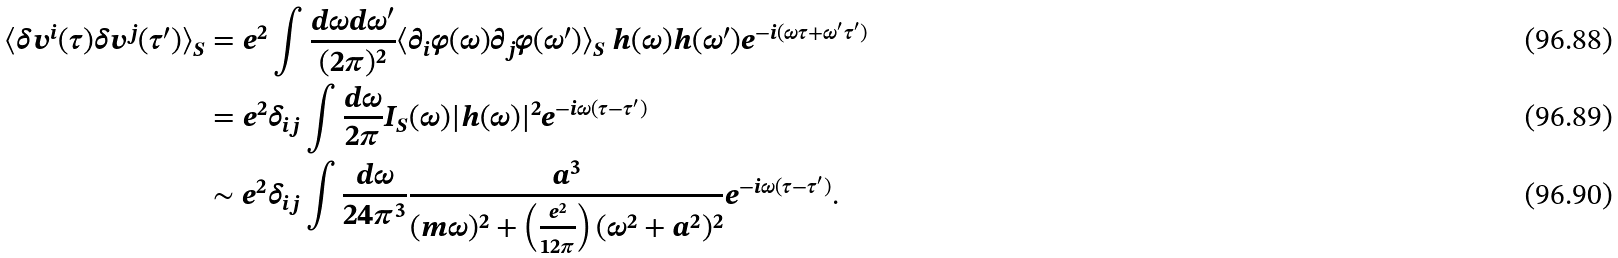Convert formula to latex. <formula><loc_0><loc_0><loc_500><loc_500>\langle \delta v ^ { i } ( \tau ) \delta v ^ { j } ( \tau ^ { \prime } ) \rangle _ { S } & = e ^ { 2 } \int \frac { d \omega d \omega ^ { \prime } } { ( 2 \pi ) ^ { 2 } } \langle \partial _ { i } \varphi ( \omega ) \partial _ { j } \varphi ( \omega ^ { \prime } ) \rangle _ { S } \ h ( \omega ) h ( \omega ^ { \prime } ) e ^ { - i ( \omega \tau + \omega ^ { \prime } \tau ^ { \prime } ) } \\ & = e ^ { 2 } \delta _ { i j } \int \frac { d \omega } { 2 \pi } I _ { S } ( \omega ) | h ( \omega ) | ^ { 2 } e ^ { - i \omega ( \tau - \tau ^ { \prime } ) } \\ & \sim e ^ { 2 } \delta _ { i j } \int \frac { d \omega } { 2 4 \pi ^ { 3 } } \frac { a ^ { 3 } } { ( m \omega ) ^ { 2 } + \left ( \frac { e ^ { 2 } } { 1 2 \pi } \right ) ( \omega ^ { 2 } + a ^ { 2 } ) ^ { 2 } } e ^ { - i \omega ( \tau - \tau ^ { \prime } ) } .</formula> 